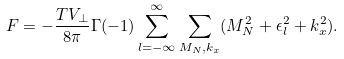Convert formula to latex. <formula><loc_0><loc_0><loc_500><loc_500>F = - \frac { T V _ { \perp } } { 8 \pi } \Gamma ( - 1 ) \sum _ { l = - \infty } ^ { \infty } \sum _ { M _ { N } , k _ { x } } ( M _ { N } ^ { 2 } + \epsilon _ { l } ^ { 2 } + k _ { x } ^ { 2 } ) .</formula> 